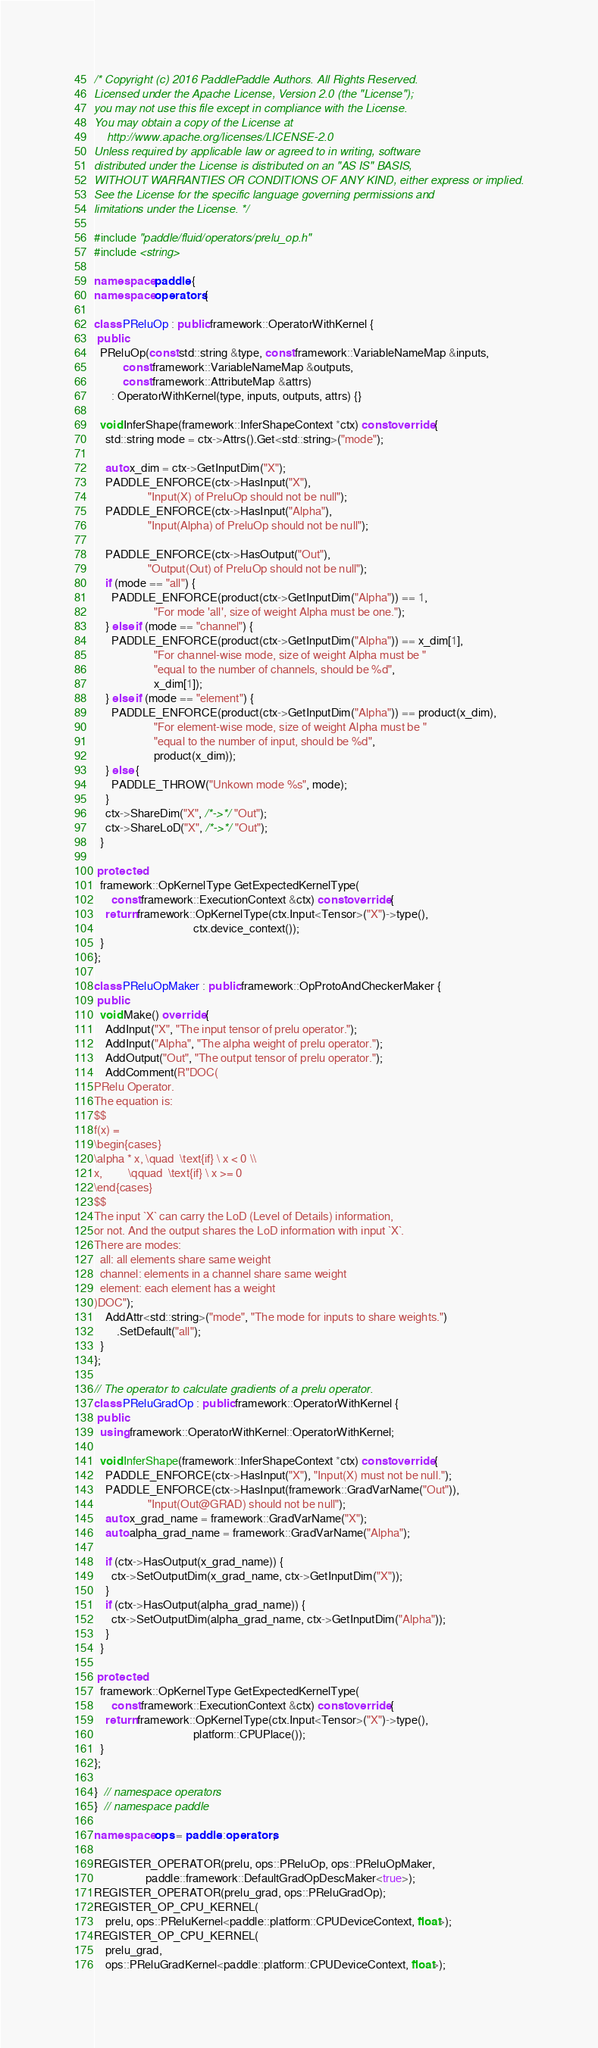Convert code to text. <code><loc_0><loc_0><loc_500><loc_500><_C++_>/* Copyright (c) 2016 PaddlePaddle Authors. All Rights Reserved.
Licensed under the Apache License, Version 2.0 (the "License");
you may not use this file except in compliance with the License.
You may obtain a copy of the License at
    http://www.apache.org/licenses/LICENSE-2.0
Unless required by applicable law or agreed to in writing, software
distributed under the License is distributed on an "AS IS" BASIS,
WITHOUT WARRANTIES OR CONDITIONS OF ANY KIND, either express or implied.
See the License for the specific language governing permissions and
limitations under the License. */

#include "paddle/fluid/operators/prelu_op.h"
#include <string>

namespace paddle {
namespace operators {

class PReluOp : public framework::OperatorWithKernel {
 public:
  PReluOp(const std::string &type, const framework::VariableNameMap &inputs,
          const framework::VariableNameMap &outputs,
          const framework::AttributeMap &attrs)
      : OperatorWithKernel(type, inputs, outputs, attrs) {}

  void InferShape(framework::InferShapeContext *ctx) const override {
    std::string mode = ctx->Attrs().Get<std::string>("mode");

    auto x_dim = ctx->GetInputDim("X");
    PADDLE_ENFORCE(ctx->HasInput("X"),
                   "Input(X) of PreluOp should not be null");
    PADDLE_ENFORCE(ctx->HasInput("Alpha"),
                   "Input(Alpha) of PreluOp should not be null");

    PADDLE_ENFORCE(ctx->HasOutput("Out"),
                   "Output(Out) of PreluOp should not be null");
    if (mode == "all") {
      PADDLE_ENFORCE(product(ctx->GetInputDim("Alpha")) == 1,
                     "For mode 'all', size of weight Alpha must be one.");
    } else if (mode == "channel") {
      PADDLE_ENFORCE(product(ctx->GetInputDim("Alpha")) == x_dim[1],
                     "For channel-wise mode, size of weight Alpha must be "
                     "equal to the number of channels, should be %d",
                     x_dim[1]);
    } else if (mode == "element") {
      PADDLE_ENFORCE(product(ctx->GetInputDim("Alpha")) == product(x_dim),
                     "For element-wise mode, size of weight Alpha must be "
                     "equal to the number of input, should be %d",
                     product(x_dim));
    } else {
      PADDLE_THROW("Unkown mode %s", mode);
    }
    ctx->ShareDim("X", /*->*/ "Out");
    ctx->ShareLoD("X", /*->*/ "Out");
  }

 protected:
  framework::OpKernelType GetExpectedKernelType(
      const framework::ExecutionContext &ctx) const override {
    return framework::OpKernelType(ctx.Input<Tensor>("X")->type(),
                                   ctx.device_context());
  }
};

class PReluOpMaker : public framework::OpProtoAndCheckerMaker {
 public:
  void Make() override {
    AddInput("X", "The input tensor of prelu operator.");
    AddInput("Alpha", "The alpha weight of prelu operator.");
    AddOutput("Out", "The output tensor of prelu operator.");
    AddComment(R"DOC(
PRelu Operator.
The equation is:
$$
f(x) =
\begin{cases}
\alpha * x, \quad  \text{if} \ x < 0 \\
x,         \qquad  \text{if} \ x >= 0
\end{cases}
$$
The input `X` can carry the LoD (Level of Details) information,
or not. And the output shares the LoD information with input `X`.
There are modes: 
  all: all elements share same weight
  channel: elements in a channel share same weight
  element: each element has a weight 
)DOC");
    AddAttr<std::string>("mode", "The mode for inputs to share weights.")
        .SetDefault("all");
  }
};

// The operator to calculate gradients of a prelu operator.
class PReluGradOp : public framework::OperatorWithKernel {
 public:
  using framework::OperatorWithKernel::OperatorWithKernel;

  void InferShape(framework::InferShapeContext *ctx) const override {
    PADDLE_ENFORCE(ctx->HasInput("X"), "Input(X) must not be null.");
    PADDLE_ENFORCE(ctx->HasInput(framework::GradVarName("Out")),
                   "Input(Out@GRAD) should not be null");
    auto x_grad_name = framework::GradVarName("X");
    auto alpha_grad_name = framework::GradVarName("Alpha");

    if (ctx->HasOutput(x_grad_name)) {
      ctx->SetOutputDim(x_grad_name, ctx->GetInputDim("X"));
    }
    if (ctx->HasOutput(alpha_grad_name)) {
      ctx->SetOutputDim(alpha_grad_name, ctx->GetInputDim("Alpha"));
    }
  }

 protected:
  framework::OpKernelType GetExpectedKernelType(
      const framework::ExecutionContext &ctx) const override {
    return framework::OpKernelType(ctx.Input<Tensor>("X")->type(),
                                   platform::CPUPlace());
  }
};

}  // namespace operators
}  // namespace paddle

namespace ops = paddle::operators;

REGISTER_OPERATOR(prelu, ops::PReluOp, ops::PReluOpMaker,
                  paddle::framework::DefaultGradOpDescMaker<true>);
REGISTER_OPERATOR(prelu_grad, ops::PReluGradOp);
REGISTER_OP_CPU_KERNEL(
    prelu, ops::PReluKernel<paddle::platform::CPUDeviceContext, float>);
REGISTER_OP_CPU_KERNEL(
    prelu_grad,
    ops::PReluGradKernel<paddle::platform::CPUDeviceContext, float>);
</code> 